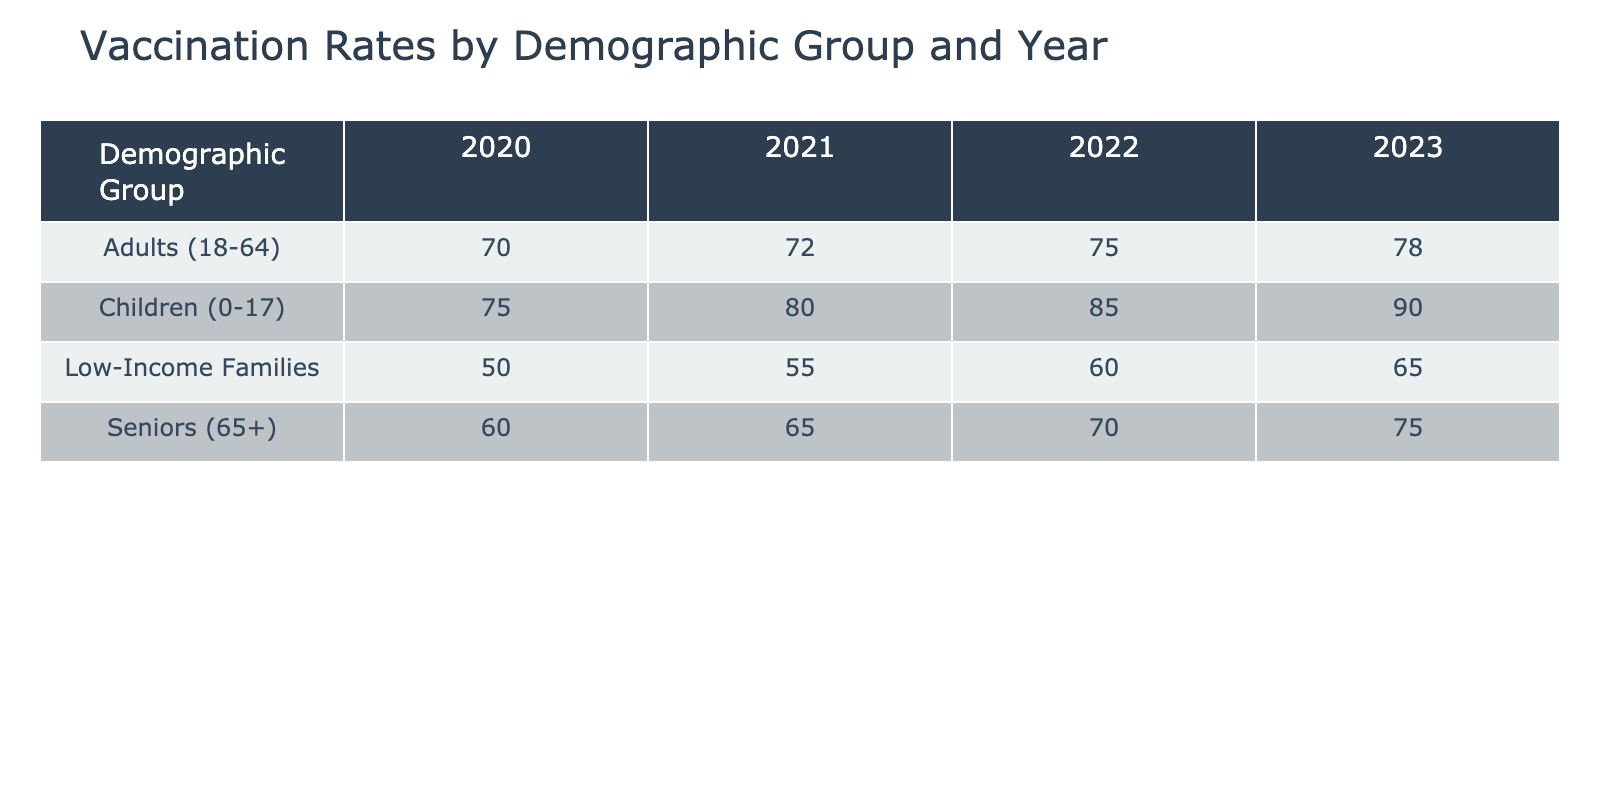What was the vaccination rate for children in 2022? The table shows the vaccination rate for children (0-17) in 2022, which is clearly listed as 85%.
Answer: 85% What is the vaccination rate for seniors in 2021 compared to 2023? For seniors (65+) in 2021, the vaccination rate is 65%, and in 2023, it is 75%. Thus, the rate increased by 10 percentage points over the two years.
Answer: 10 percentage points Was the vaccination rate for low-income families higher in 2021 or 2022? The vaccination rate for low-income families in 2021 is 55%, while in 2022 it increased to 60%. Therefore, the rate is higher in 2022.
Answer: 2022 What is the average vaccination rate for adults from 2020 to 2023? The vaccination rates for adults over the years are: 70% (2020), 72% (2021), 75% (2022), and 78% (2023). To find the average: (70 + 72 + 75 + 78) / 4 = 73.75%.
Answer: 73.75% Is the vaccination rate for children consistently higher than that for seniors from 2020 to 2023? Observing the table, the vaccination rates for children are: 75% (2020), 80% (2021), 85% (2022), and 90% (2023), whereas for seniors, the rates are 60% (2020), 65% (2021), 70% (2022), and 75% (2023). Children always have higher rates than seniors in all listed years.
Answer: Yes How much did the vaccination rate for low-income families increase from 2020 to 2023? The vaccination rate for low-income families was 50% in 2020 and increased to 65% in 2023. The increase is calculated as 65% - 50% = 15%.
Answer: 15% What is the difference in the vaccination rate for children between 2021 and 2022? The vaccination rates for children are 80% in 2021 and 85% in 2022. The difference is calculated as 85% - 80% = 5%.
Answer: 5% Are there any years where the vaccination rate for seniors was higher than for adults? The table shows that seniors have rates of 60%, 65%, 70%, and 75% from 2020 to 2023, while adults have rates of 70%, 72%, 75%, and 78%. The rates for seniors are never higher than those for adults in any year.
Answer: No 